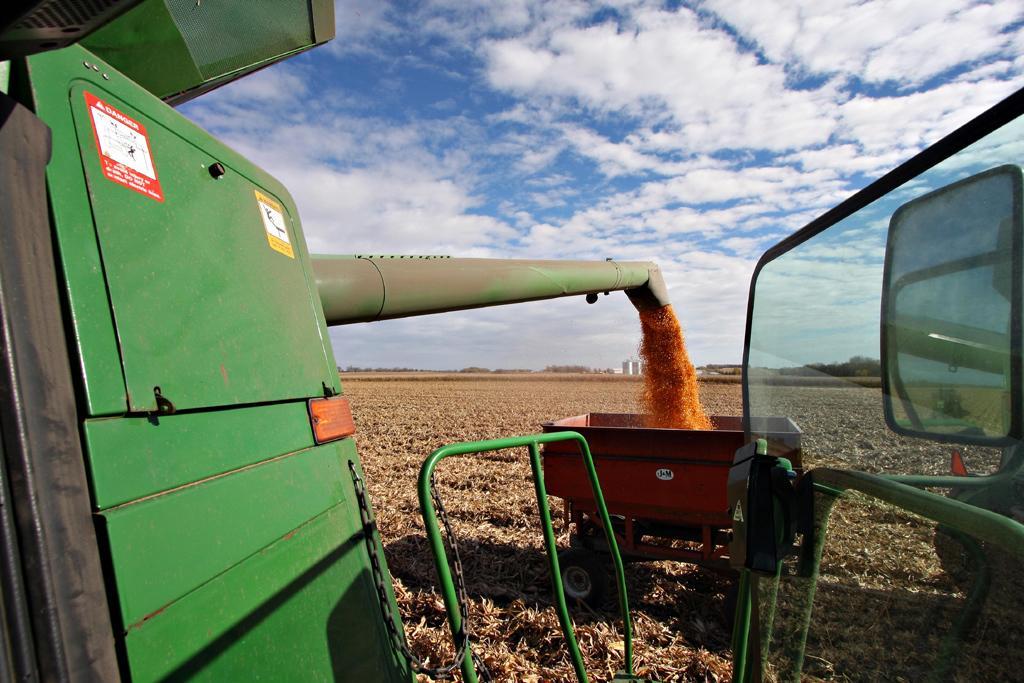Could you give a brief overview of what you see in this image? In this picture we can see a machine and a trolley. There is a dry grass on the ground from left to right. We can see a few trees in the background. 